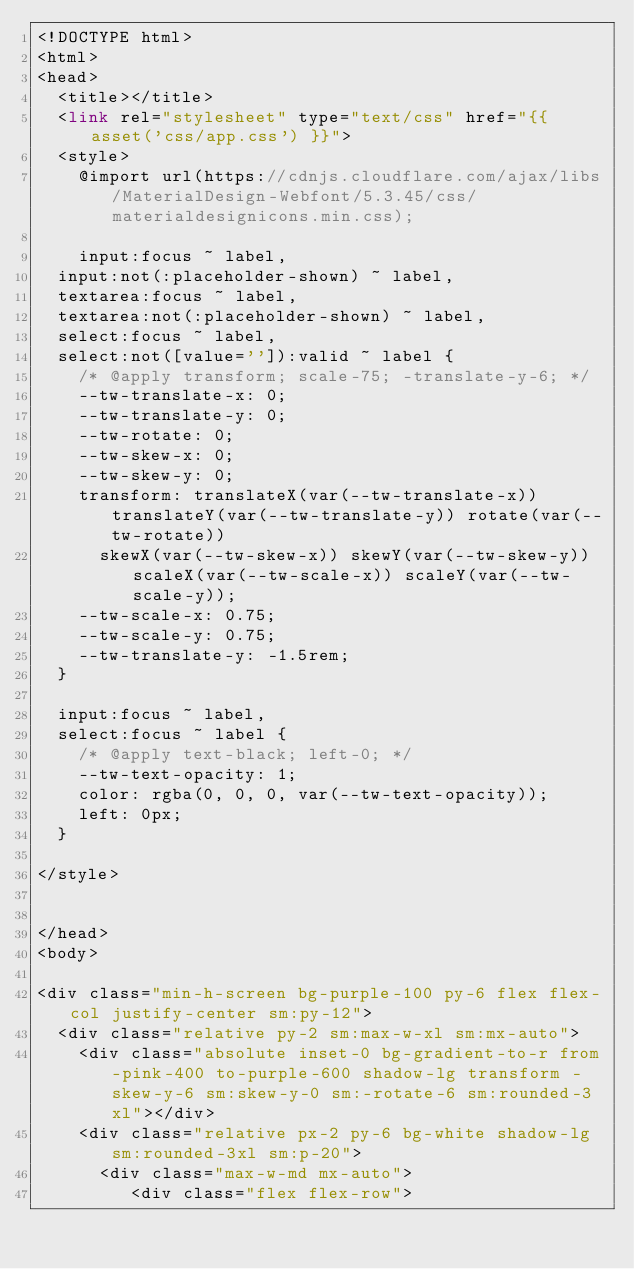<code> <loc_0><loc_0><loc_500><loc_500><_PHP_><!DOCTYPE html>
<html>
<head>
  <title></title>
  <link rel="stylesheet" type="text/css" href="{{ asset('css/app.css') }}">
  <style>
    @import url(https://cdnjs.cloudflare.com/ajax/libs/MaterialDesign-Webfont/5.3.45/css/materialdesignicons.min.css);

    input:focus ~ label,
  input:not(:placeholder-shown) ~ label,
  textarea:focus ~ label,
  textarea:not(:placeholder-shown) ~ label,
  select:focus ~ label,
  select:not([value='']):valid ~ label {
    /* @apply transform; scale-75; -translate-y-6; */
    --tw-translate-x: 0;
    --tw-translate-y: 0;
    --tw-rotate: 0;
    --tw-skew-x: 0;
    --tw-skew-y: 0;
    transform: translateX(var(--tw-translate-x)) translateY(var(--tw-translate-y)) rotate(var(--tw-rotate))
      skewX(var(--tw-skew-x)) skewY(var(--tw-skew-y)) scaleX(var(--tw-scale-x)) scaleY(var(--tw-scale-y));
    --tw-scale-x: 0.75;
    --tw-scale-y: 0.75;
    --tw-translate-y: -1.5rem;
  }

  input:focus ~ label,
  select:focus ~ label {
    /* @apply text-black; left-0; */
    --tw-text-opacity: 1;
    color: rgba(0, 0, 0, var(--tw-text-opacity));
    left: 0px;
  }

</style>


</head>
<body>

<div class="min-h-screen bg-purple-100 py-6 flex flex-col justify-center sm:py-12">
  <div class="relative py-2 sm:max-w-xl sm:mx-auto">
    <div class="absolute inset-0 bg-gradient-to-r from-pink-400 to-purple-600 shadow-lg transform -skew-y-6 sm:skew-y-0 sm:-rotate-6 sm:rounded-3xl"></div>
    <div class="relative px-2 py-6 bg-white shadow-lg sm:rounded-3xl sm:p-20">
      <div class="max-w-md mx-auto">
         <div class="flex flex-row">
</code> 